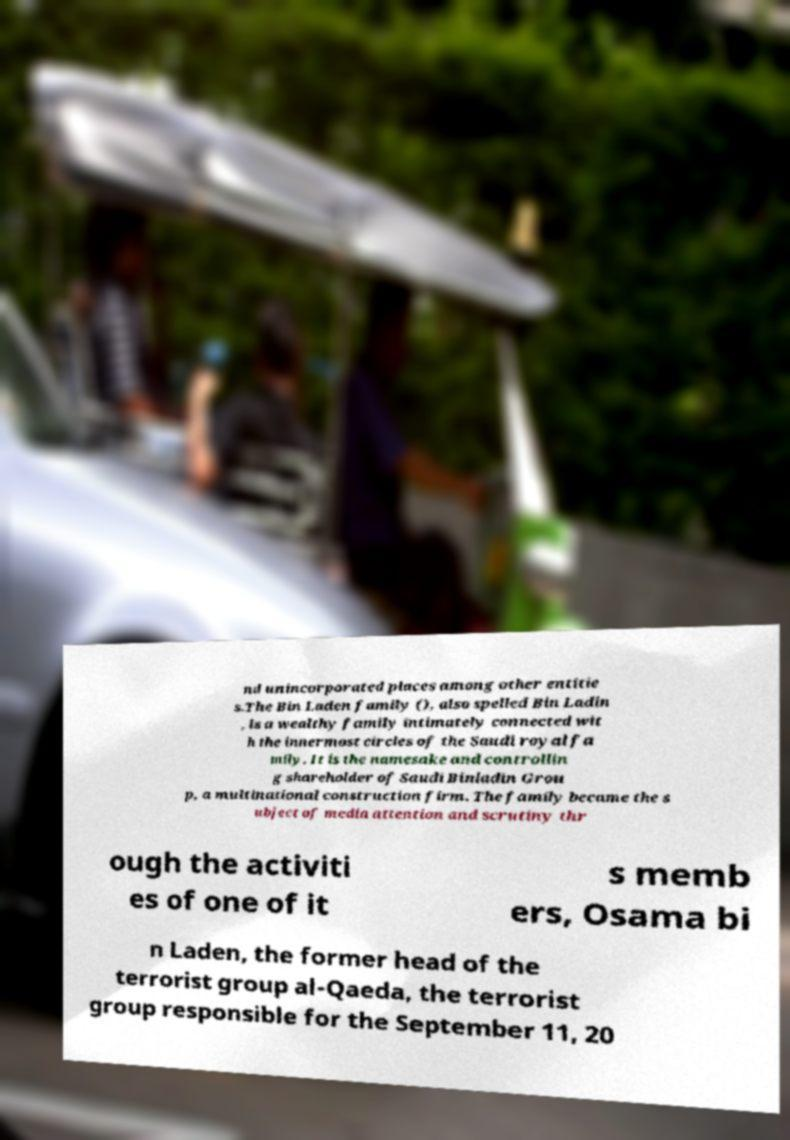Can you accurately transcribe the text from the provided image for me? nd unincorporated places among other entitie s.The Bin Laden family (), also spelled Bin Ladin , is a wealthy family intimately connected wit h the innermost circles of the Saudi royal fa mily. It is the namesake and controllin g shareholder of Saudi Binladin Grou p, a multinational construction firm. The family became the s ubject of media attention and scrutiny thr ough the activiti es of one of it s memb ers, Osama bi n Laden, the former head of the terrorist group al-Qaeda, the terrorist group responsible for the September 11, 20 